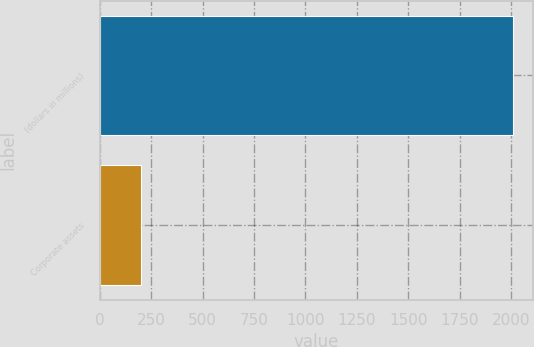Convert chart to OTSL. <chart><loc_0><loc_0><loc_500><loc_500><bar_chart><fcel>(dollars in millions)<fcel>Corporate assets<nl><fcel>2008<fcel>202.5<nl></chart> 